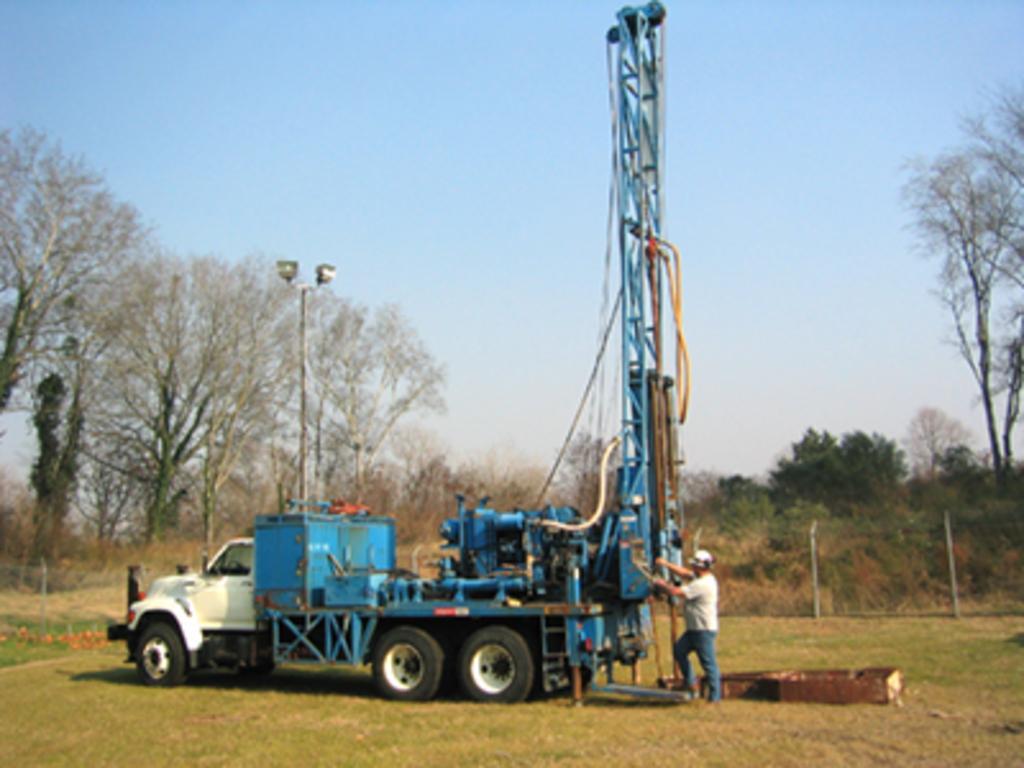Can you describe this image briefly? This picture is clicked outside. In the center there is a truck parked on the ground. The ground is covered with the green grass. On the right there is a person standing on the ground and seems to be working and we can see the metal rods, some objects placed on the ground. In the background there is a sky, trees and lights attached to the pole and some plants. 